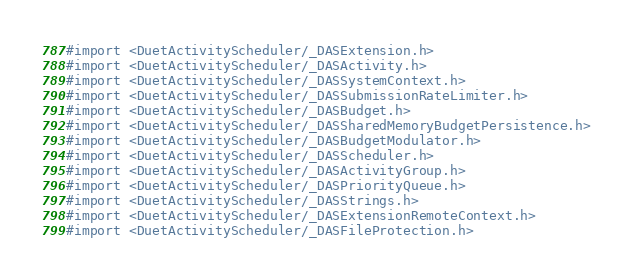Convert code to text. <code><loc_0><loc_0><loc_500><loc_500><_C_>#import <DuetActivityScheduler/_DASExtension.h>
#import <DuetActivityScheduler/_DASActivity.h>
#import <DuetActivityScheduler/_DASSystemContext.h>
#import <DuetActivityScheduler/_DASSubmissionRateLimiter.h>
#import <DuetActivityScheduler/_DASBudget.h>
#import <DuetActivityScheduler/_DASSharedMemoryBudgetPersistence.h>
#import <DuetActivityScheduler/_DASBudgetModulator.h>
#import <DuetActivityScheduler/_DASScheduler.h>
#import <DuetActivityScheduler/_DASActivityGroup.h>
#import <DuetActivityScheduler/_DASPriorityQueue.h>
#import <DuetActivityScheduler/_DASStrings.h>
#import <DuetActivityScheduler/_DASExtensionRemoteContext.h>
#import <DuetActivityScheduler/_DASFileProtection.h>
</code> 